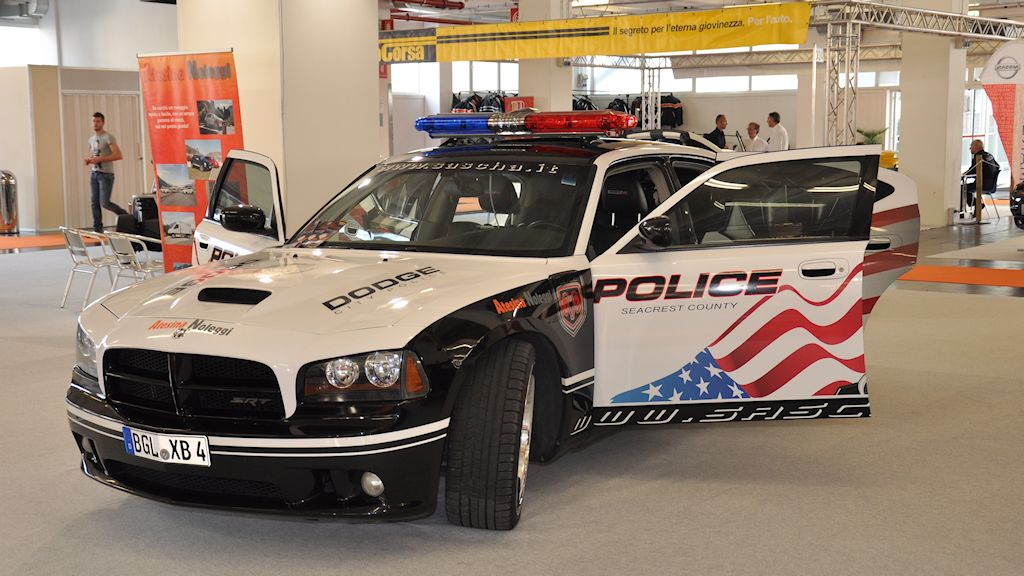Based on the design elements present on the police vehicle, what could be inferred about the intended use or the target audience for this particular vehicle? The police vehicle features a prominent American flag graphic and bold 'Seacrest County Police' branding. These elements suggest that the vehicle is intended for high visibility and recognition within the community. Its use might extend beyond regular patrols to include community engagement, acting as a public relations tool to foster trust and cooperation between law enforcement and the public. The exhibition setting further indicates that it could be employed at events to showcase local law enforcement capabilities and initiatives, aiming to captivate both residents and visiting professionals in the field of emergency services. 